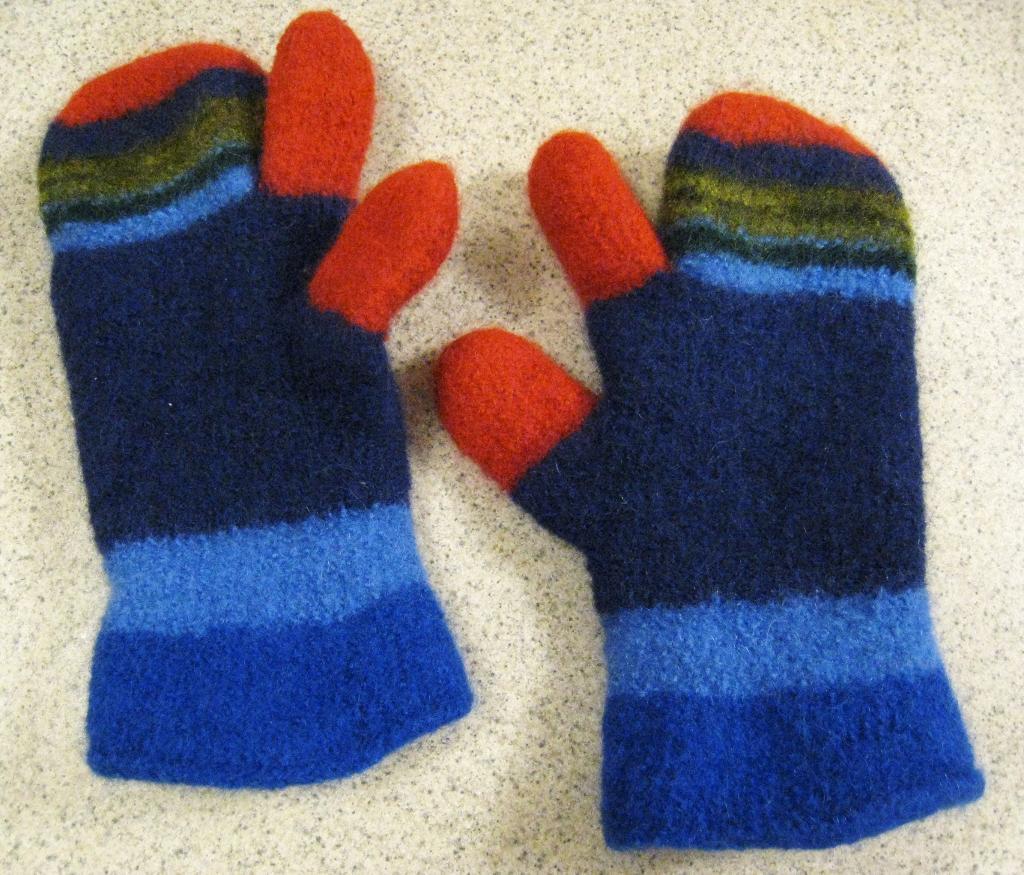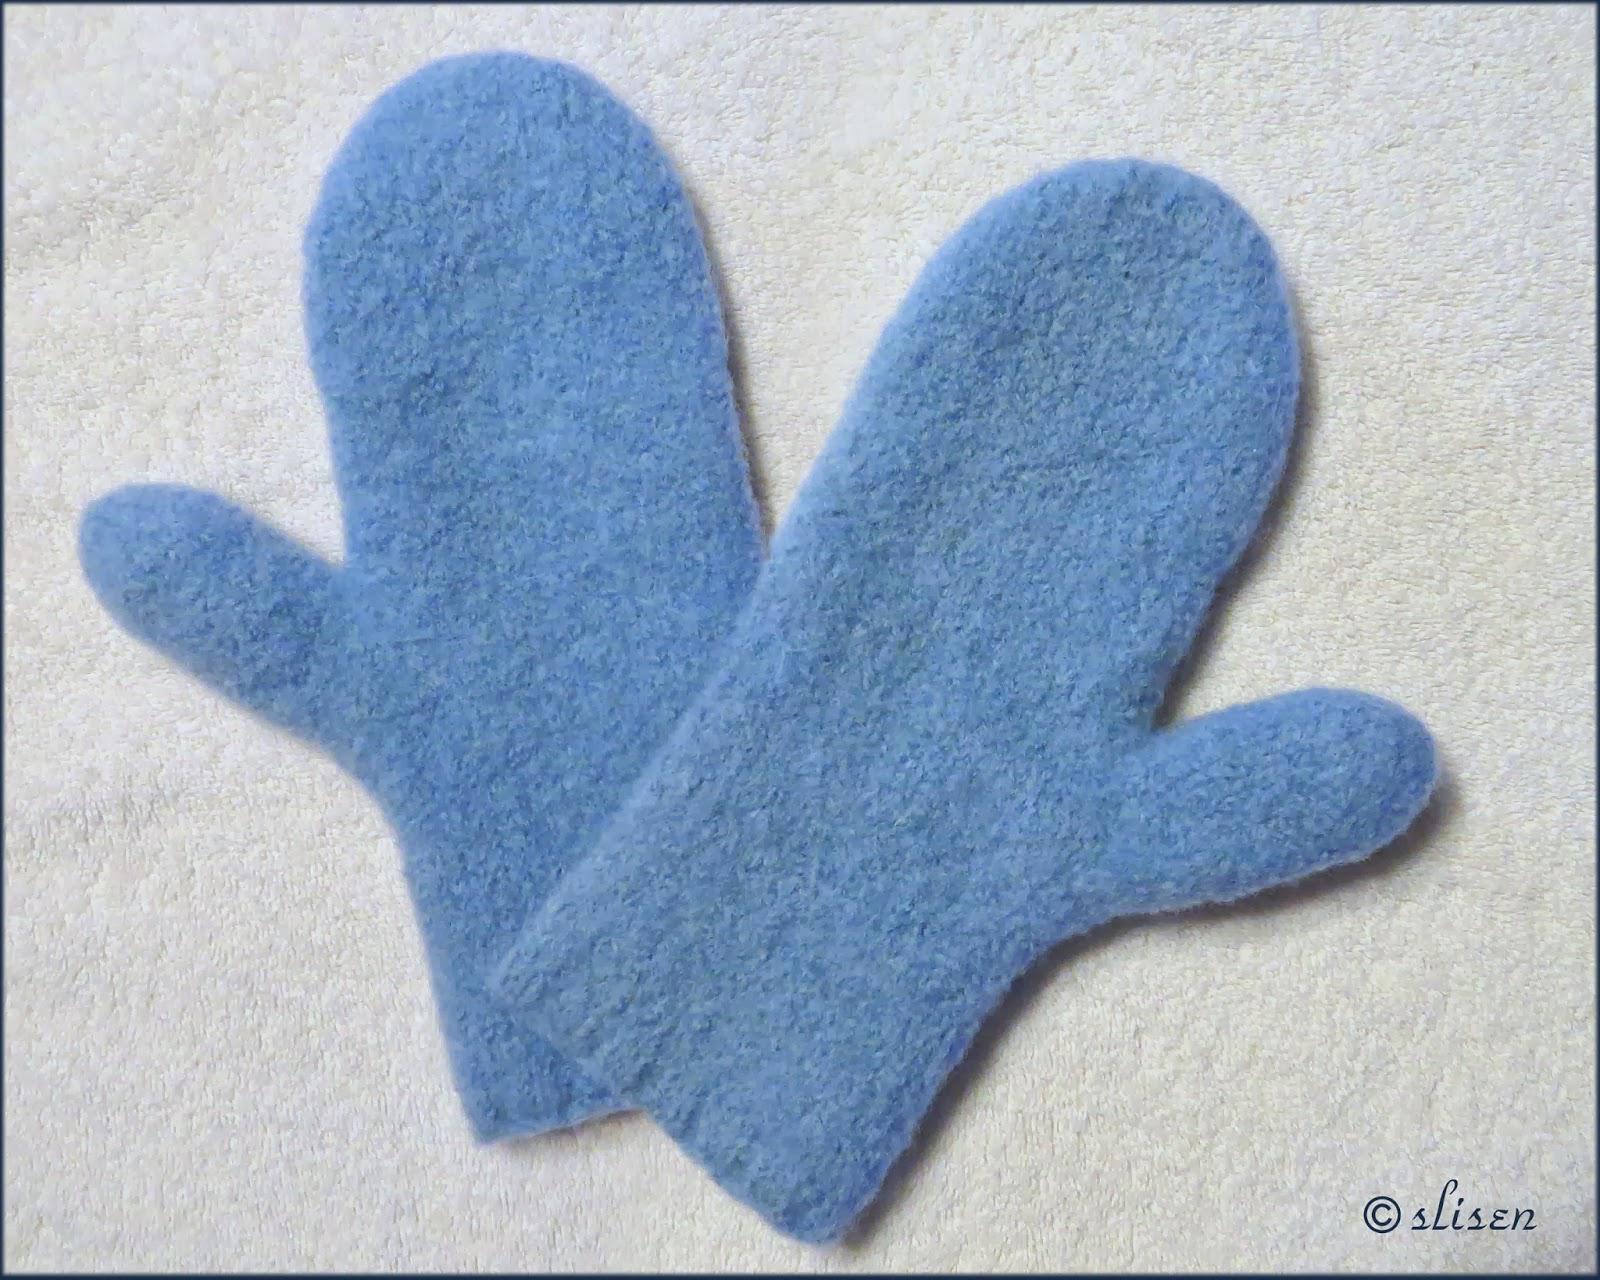The first image is the image on the left, the second image is the image on the right. Given the left and right images, does the statement "Both images have gloves over a white background." hold true? Answer yes or no. Yes. The first image is the image on the left, the second image is the image on the right. Analyze the images presented: Is the assertion "More than half of a mitten is covered by another mitten." valid? Answer yes or no. No. 